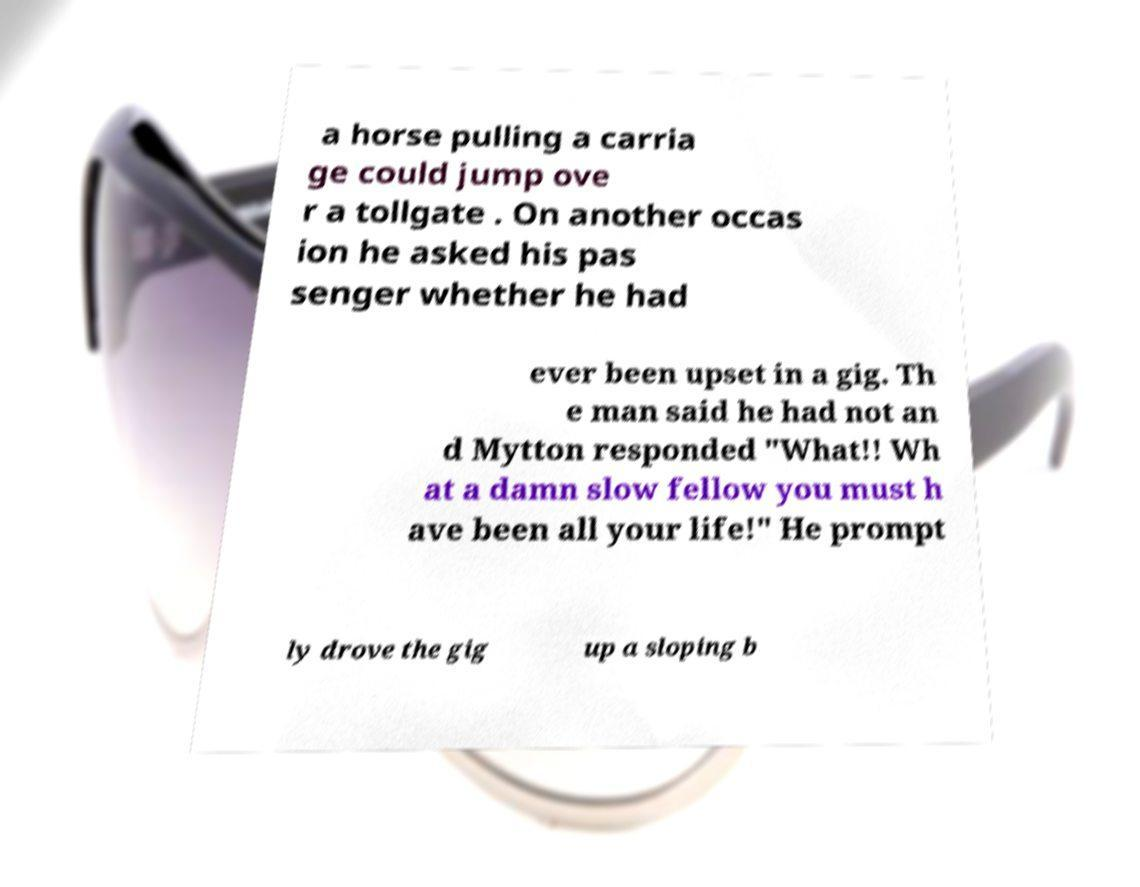For documentation purposes, I need the text within this image transcribed. Could you provide that? a horse pulling a carria ge could jump ove r a tollgate . On another occas ion he asked his pas senger whether he had ever been upset in a gig. Th e man said he had not an d Mytton responded "What!! Wh at a damn slow fellow you must h ave been all your life!" He prompt ly drove the gig up a sloping b 